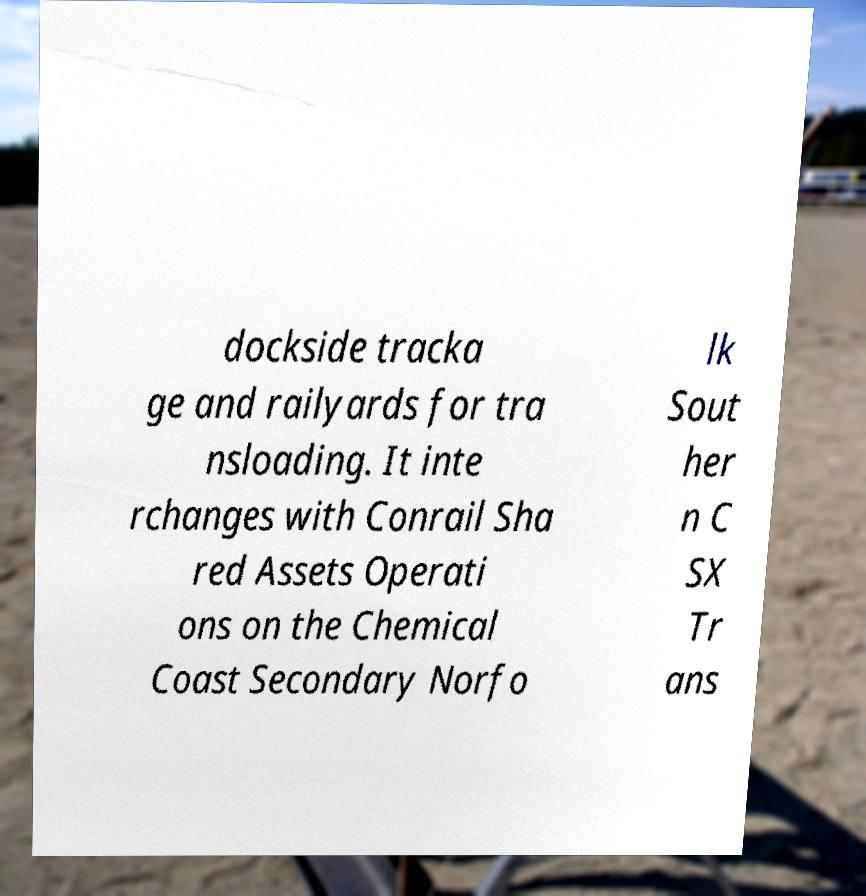Could you extract and type out the text from this image? dockside tracka ge and railyards for tra nsloading. It inte rchanges with Conrail Sha red Assets Operati ons on the Chemical Coast Secondary Norfo lk Sout her n C SX Tr ans 